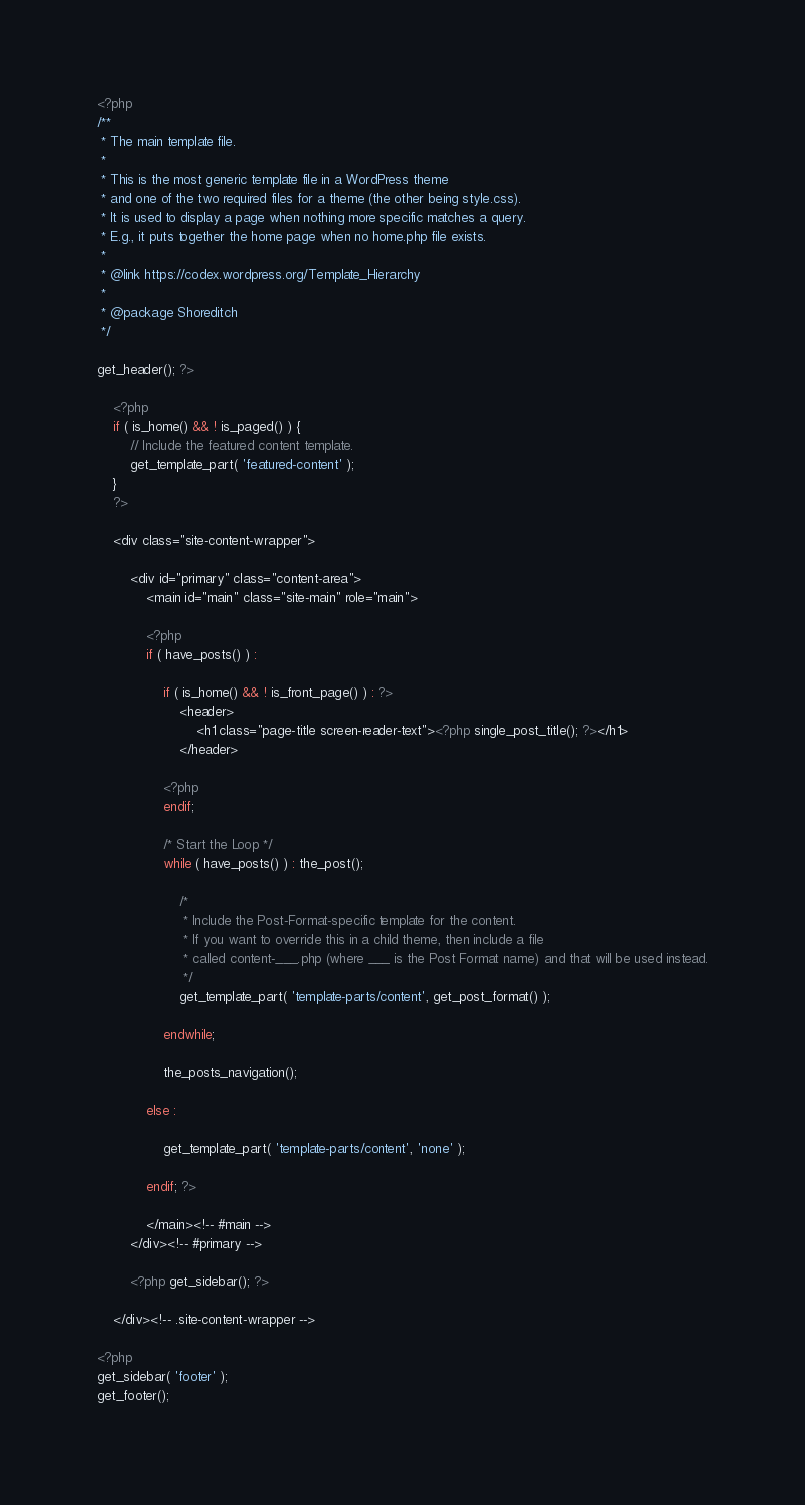Convert code to text. <code><loc_0><loc_0><loc_500><loc_500><_PHP_><?php
/**
 * The main template file.
 *
 * This is the most generic template file in a WordPress theme
 * and one of the two required files for a theme (the other being style.css).
 * It is used to display a page when nothing more specific matches a query.
 * E.g., it puts together the home page when no home.php file exists.
 *
 * @link https://codex.wordpress.org/Template_Hierarchy
 *
 * @package Shoreditch
 */

get_header(); ?>

	<?php
	if ( is_home() && ! is_paged() ) {
		// Include the featured content template.
		get_template_part( 'featured-content' );
	}
	?>

	<div class="site-content-wrapper">

		<div id="primary" class="content-area">
			<main id="main" class="site-main" role="main">

			<?php
			if ( have_posts() ) :

				if ( is_home() && ! is_front_page() ) : ?>
					<header>
						<h1 class="page-title screen-reader-text"><?php single_post_title(); ?></h1>
					</header>

				<?php
				endif;

				/* Start the Loop */
				while ( have_posts() ) : the_post();

					/*
					 * Include the Post-Format-specific template for the content.
					 * If you want to override this in a child theme, then include a file
					 * called content-___.php (where ___ is the Post Format name) and that will be used instead.
					 */
					get_template_part( 'template-parts/content', get_post_format() );

				endwhile;

				the_posts_navigation();

			else :

				get_template_part( 'template-parts/content', 'none' );

			endif; ?>

			</main><!-- #main -->
		</div><!-- #primary -->

		<?php get_sidebar(); ?>

	</div><!-- .site-content-wrapper -->

<?php
get_sidebar( 'footer' );
get_footer();
</code> 